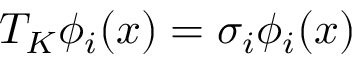<formula> <loc_0><loc_0><loc_500><loc_500>T _ { K } \phi _ { i } ( x ) = \sigma _ { i } \phi _ { i } ( x )</formula> 